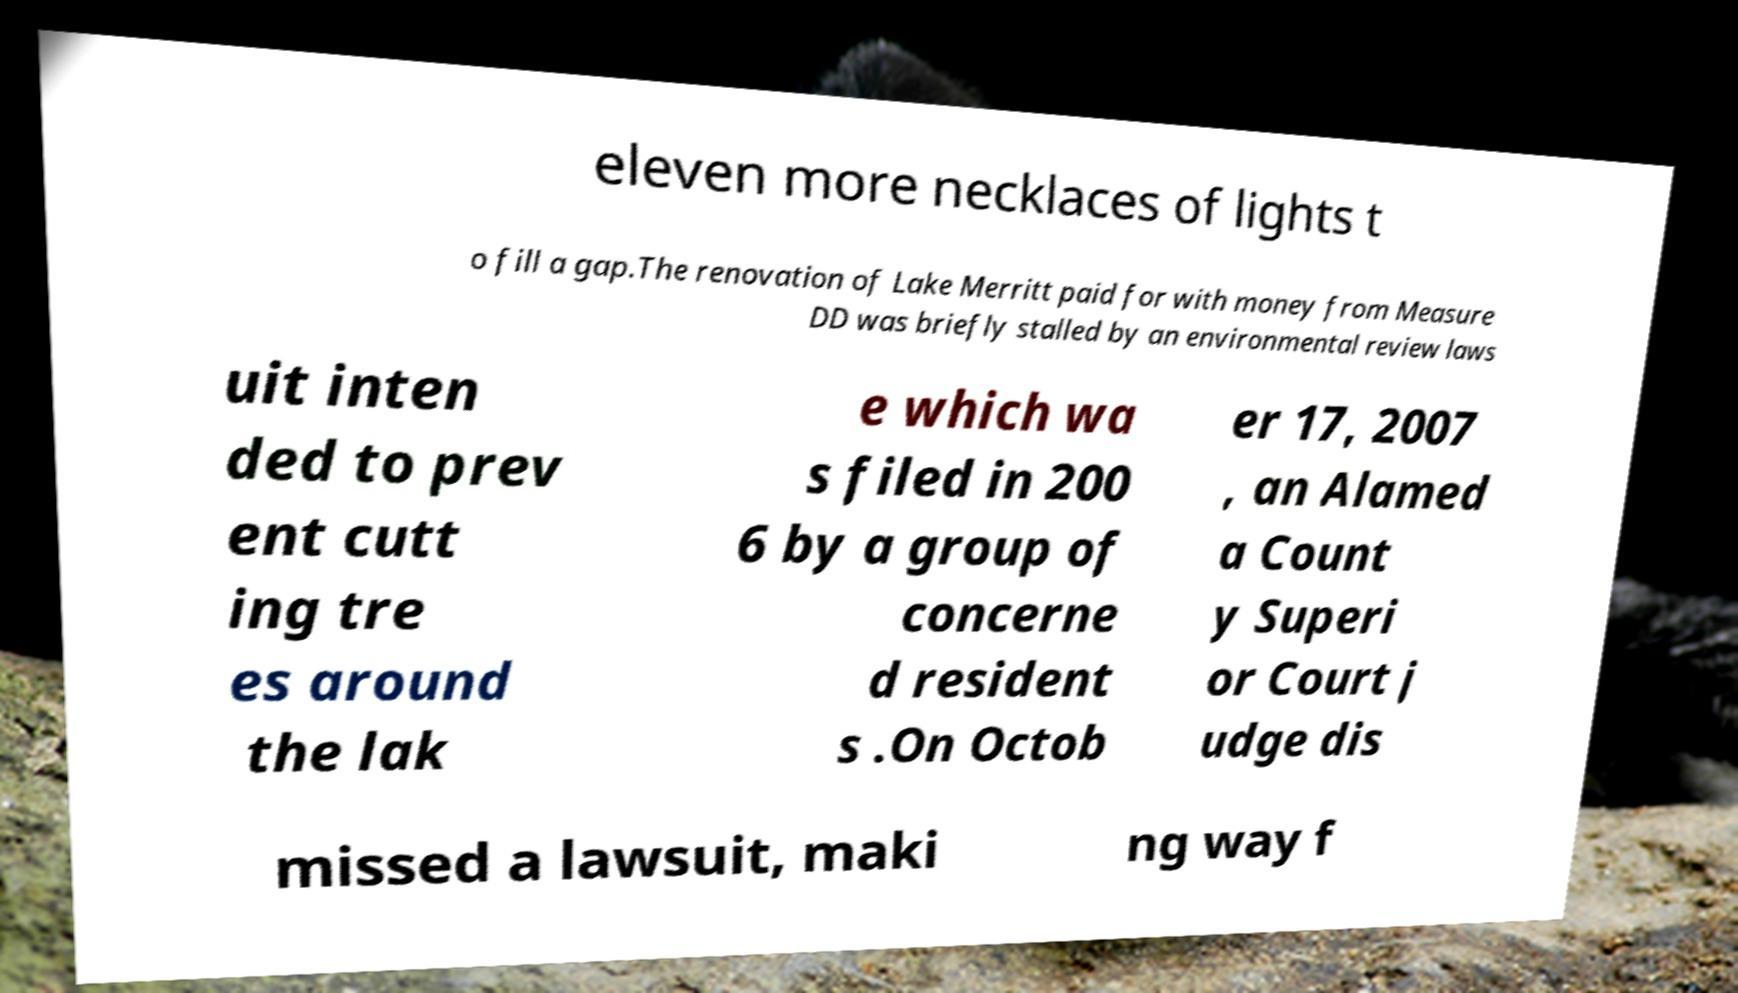Could you assist in decoding the text presented in this image and type it out clearly? eleven more necklaces of lights t o fill a gap.The renovation of Lake Merritt paid for with money from Measure DD was briefly stalled by an environmental review laws uit inten ded to prev ent cutt ing tre es around the lak e which wa s filed in 200 6 by a group of concerne d resident s .On Octob er 17, 2007 , an Alamed a Count y Superi or Court j udge dis missed a lawsuit, maki ng way f 